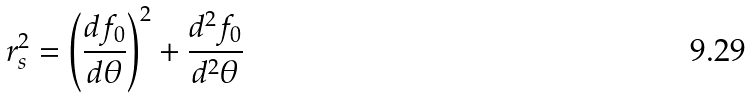Convert formula to latex. <formula><loc_0><loc_0><loc_500><loc_500>r _ { s } ^ { 2 } = \left ( \frac { d f _ { 0 } } { d \theta } \right ) ^ { 2 } + \frac { d ^ { 2 } f _ { 0 } } { d ^ { 2 } \theta }</formula> 